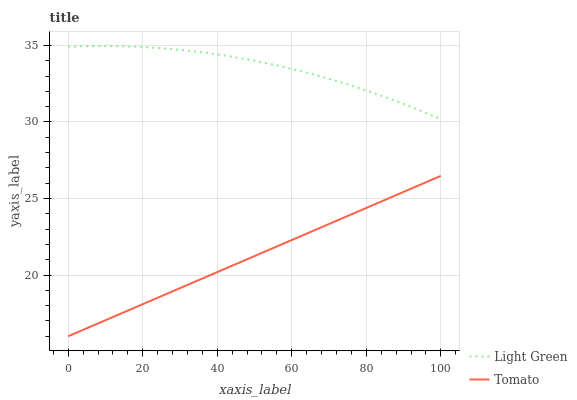Does Tomato have the minimum area under the curve?
Answer yes or no. Yes. Does Light Green have the maximum area under the curve?
Answer yes or no. Yes. Does Light Green have the minimum area under the curve?
Answer yes or no. No. Is Tomato the smoothest?
Answer yes or no. Yes. Is Light Green the roughest?
Answer yes or no. Yes. Is Light Green the smoothest?
Answer yes or no. No. Does Tomato have the lowest value?
Answer yes or no. Yes. Does Light Green have the lowest value?
Answer yes or no. No. Does Light Green have the highest value?
Answer yes or no. Yes. Is Tomato less than Light Green?
Answer yes or no. Yes. Is Light Green greater than Tomato?
Answer yes or no. Yes. Does Tomato intersect Light Green?
Answer yes or no. No. 